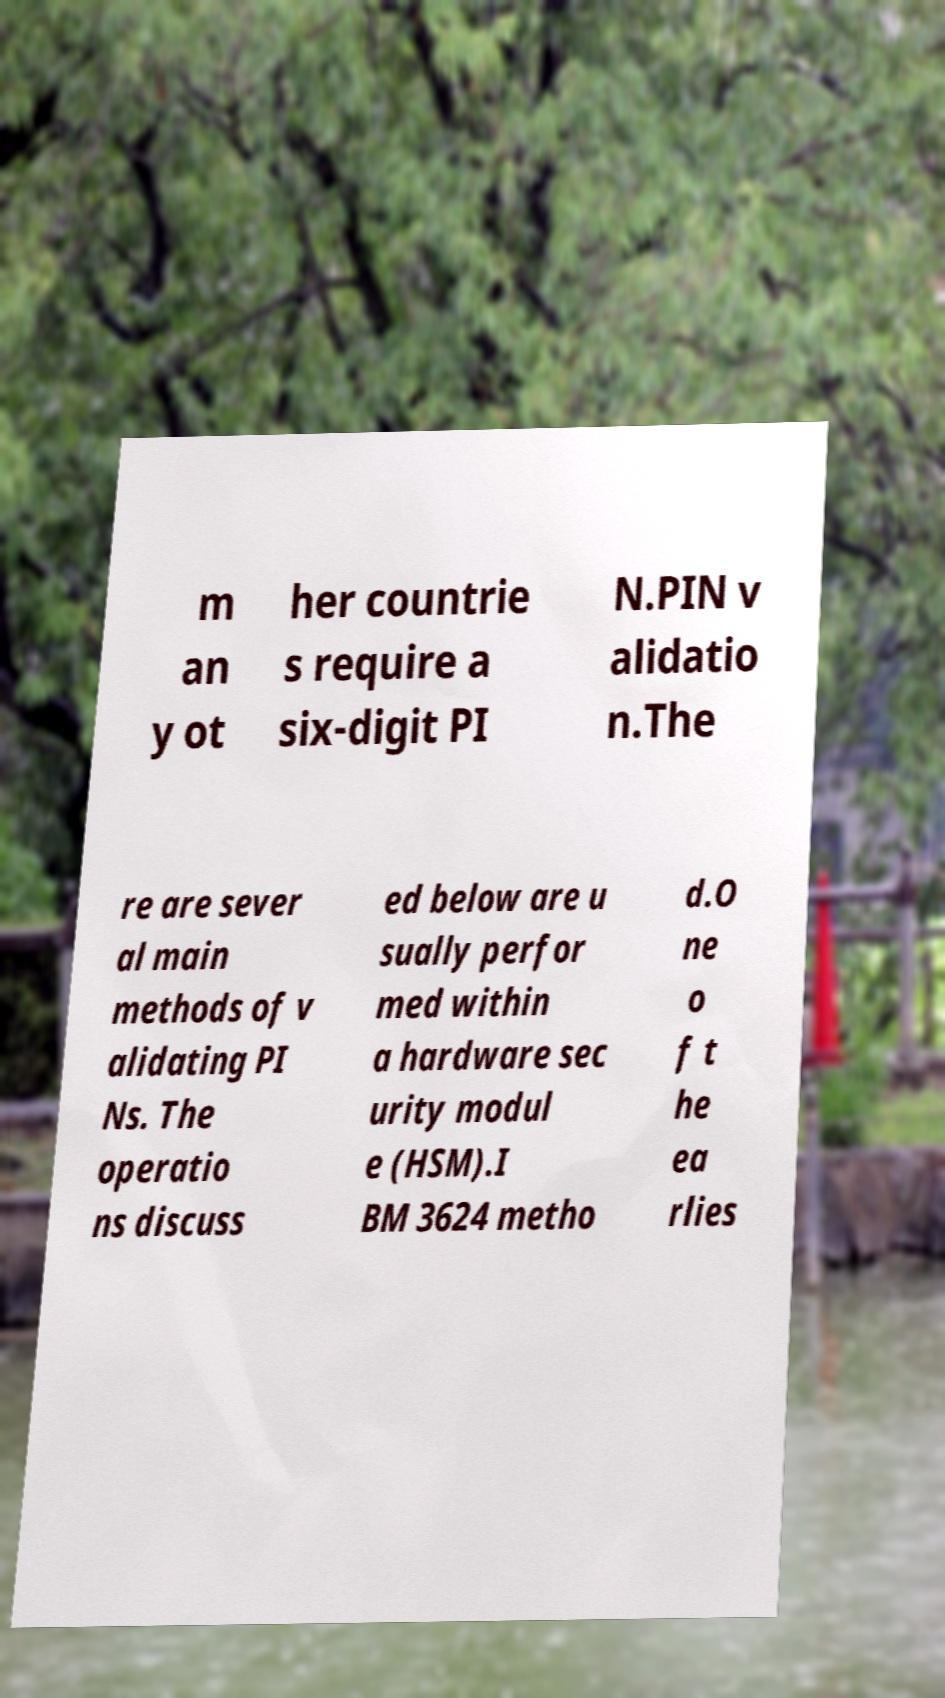For documentation purposes, I need the text within this image transcribed. Could you provide that? m an y ot her countrie s require a six-digit PI N.PIN v alidatio n.The re are sever al main methods of v alidating PI Ns. The operatio ns discuss ed below are u sually perfor med within a hardware sec urity modul e (HSM).I BM 3624 metho d.O ne o f t he ea rlies 